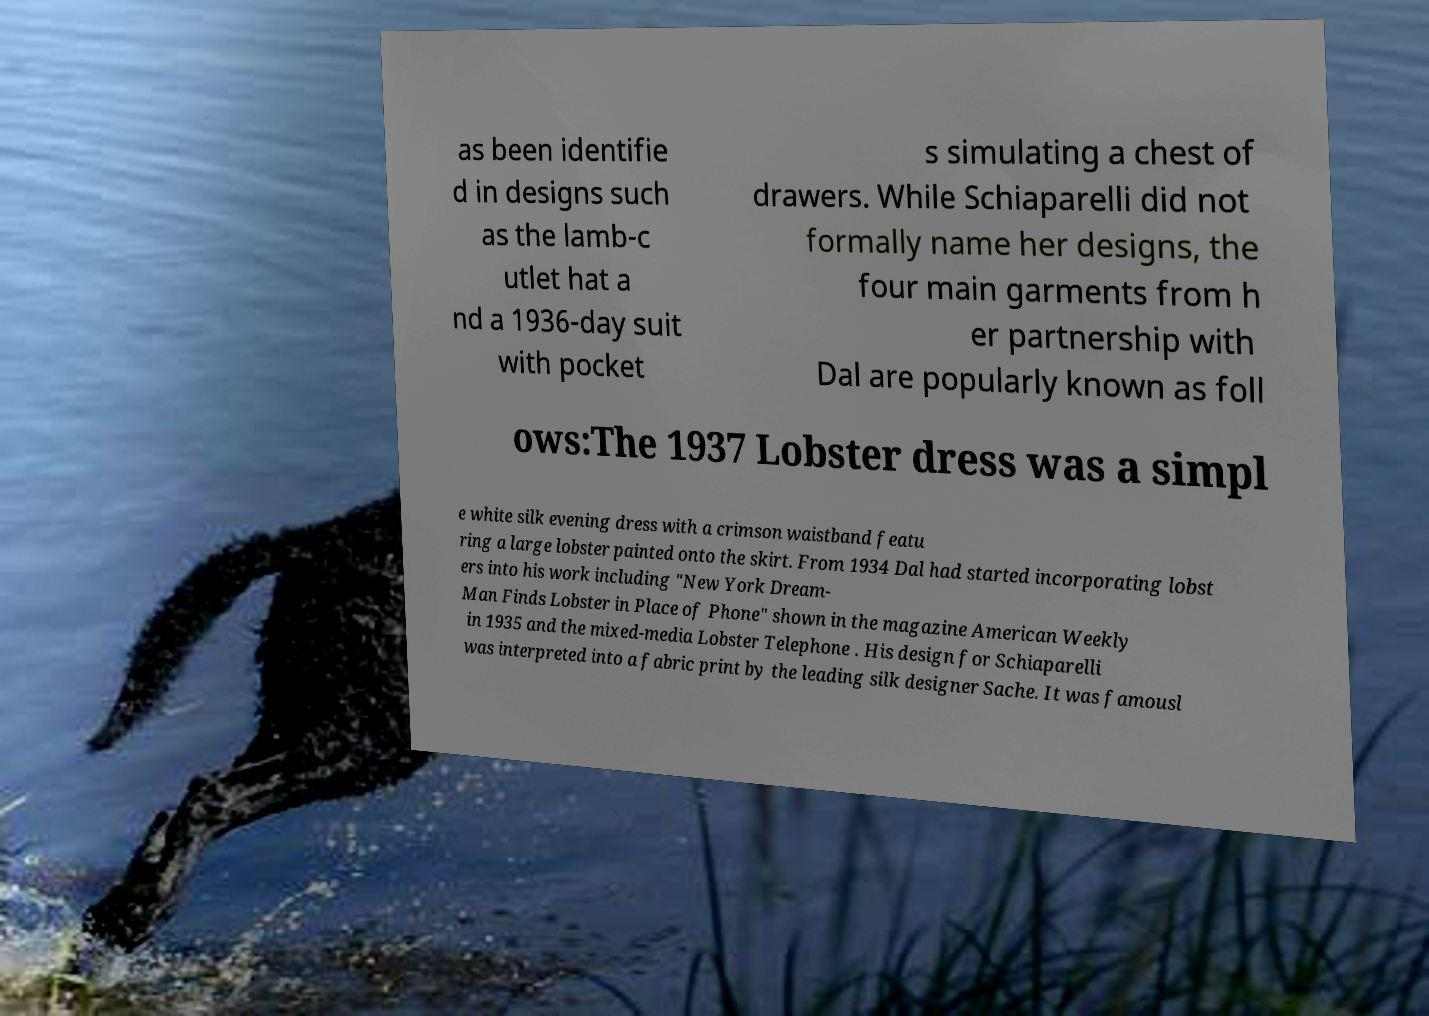Can you accurately transcribe the text from the provided image for me? as been identifie d in designs such as the lamb-c utlet hat a nd a 1936-day suit with pocket s simulating a chest of drawers. While Schiaparelli did not formally name her designs, the four main garments from h er partnership with Dal are popularly known as foll ows:The 1937 Lobster dress was a simpl e white silk evening dress with a crimson waistband featu ring a large lobster painted onto the skirt. From 1934 Dal had started incorporating lobst ers into his work including "New York Dream- Man Finds Lobster in Place of Phone" shown in the magazine American Weekly in 1935 and the mixed-media Lobster Telephone . His design for Schiaparelli was interpreted into a fabric print by the leading silk designer Sache. It was famousl 